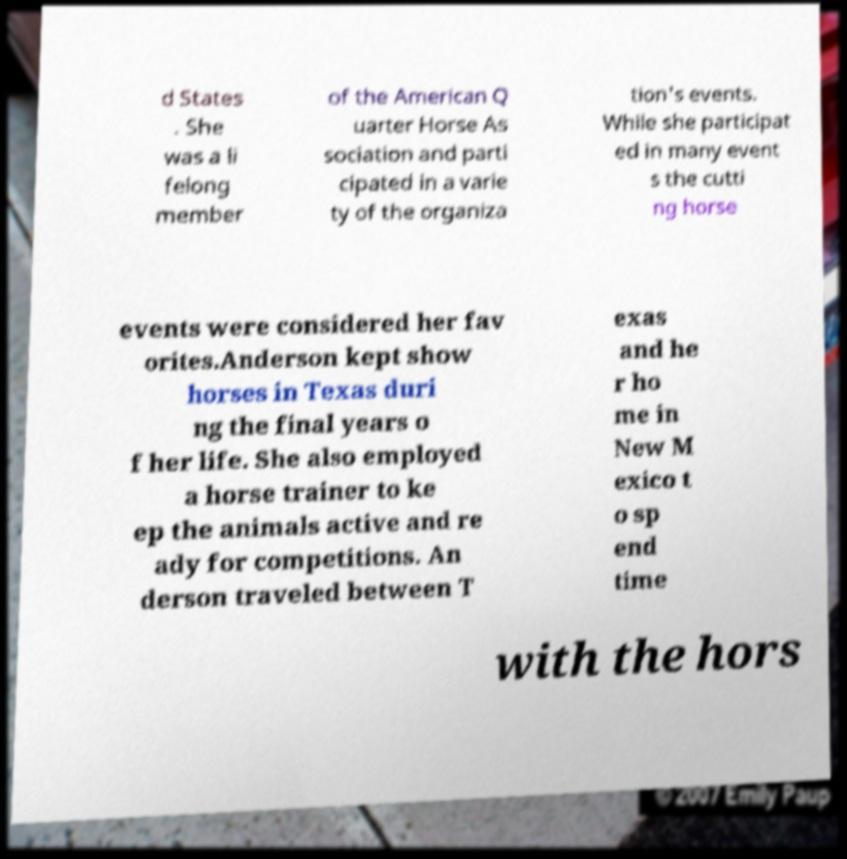Please identify and transcribe the text found in this image. d States . She was a li felong member of the American Q uarter Horse As sociation and parti cipated in a varie ty of the organiza tion's events. While she participat ed in many event s the cutti ng horse events were considered her fav orites.Anderson kept show horses in Texas duri ng the final years o f her life. She also employed a horse trainer to ke ep the animals active and re ady for competitions. An derson traveled between T exas and he r ho me in New M exico t o sp end time with the hors 